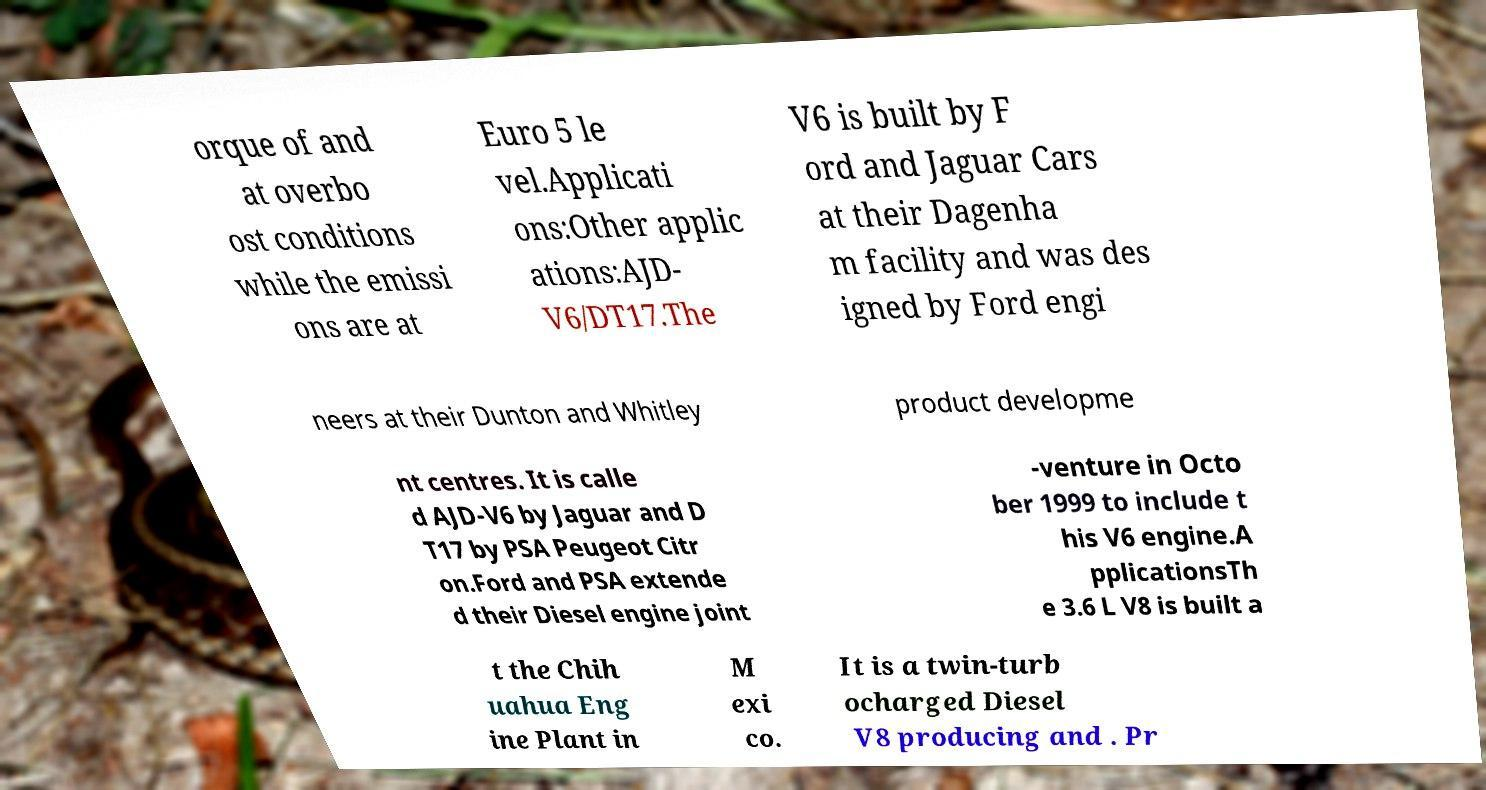Could you assist in decoding the text presented in this image and type it out clearly? orque of and at overbo ost conditions while the emissi ons are at Euro 5 le vel.Applicati ons:Other applic ations:AJD- V6/DT17.The V6 is built by F ord and Jaguar Cars at their Dagenha m facility and was des igned by Ford engi neers at their Dunton and Whitley product developme nt centres. It is calle d AJD-V6 by Jaguar and D T17 by PSA Peugeot Citr on.Ford and PSA extende d their Diesel engine joint -venture in Octo ber 1999 to include t his V6 engine.A pplicationsTh e 3.6 L V8 is built a t the Chih uahua Eng ine Plant in M exi co. It is a twin-turb ocharged Diesel V8 producing and . Pr 